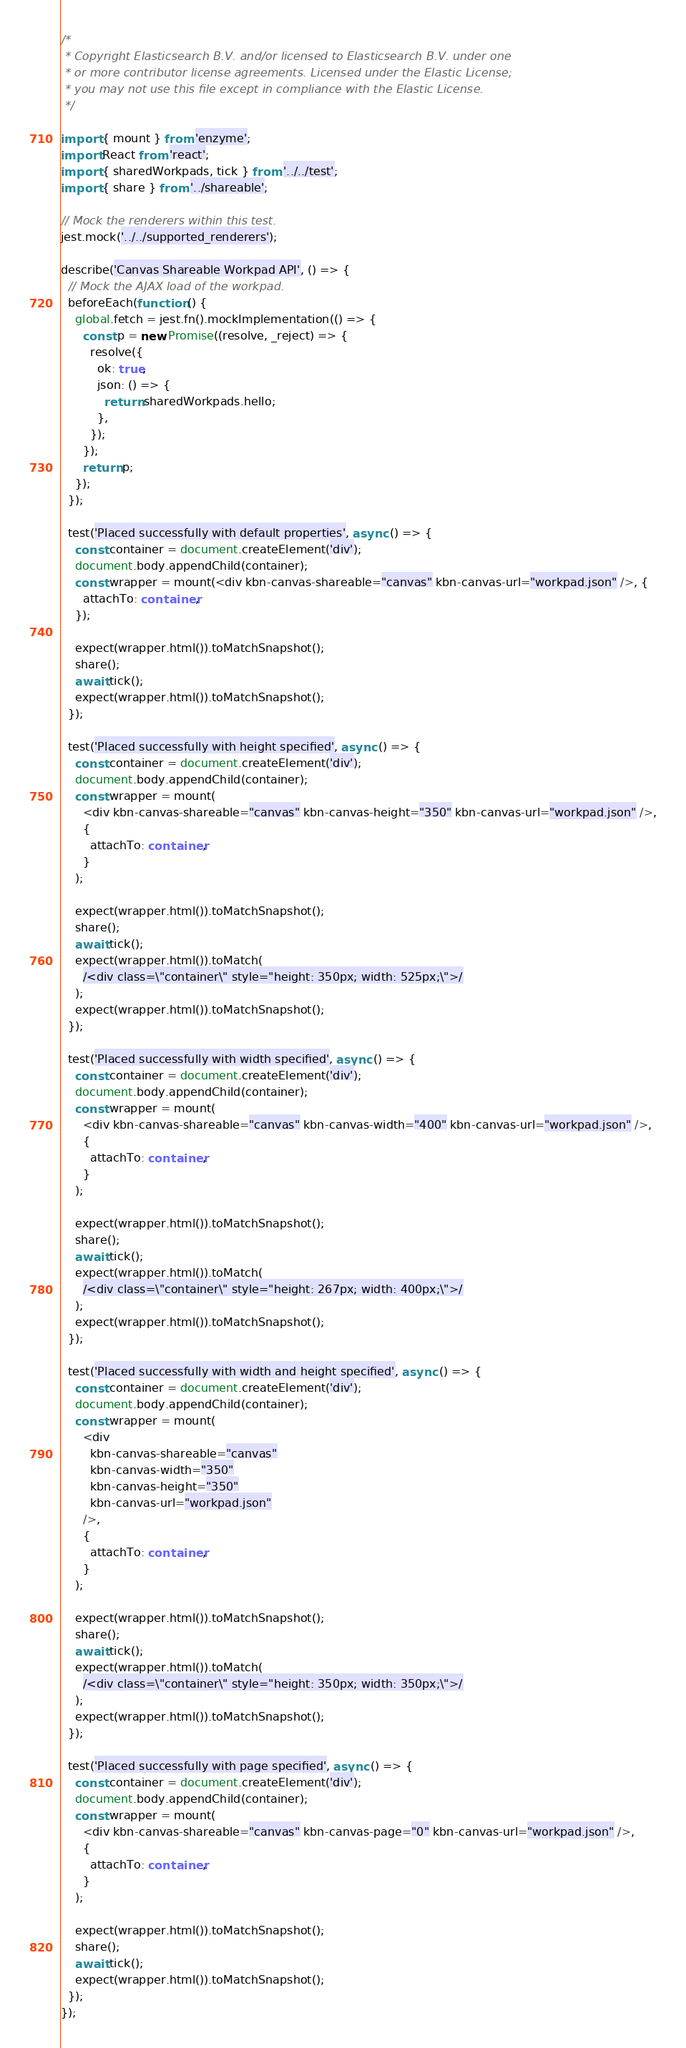Convert code to text. <code><loc_0><loc_0><loc_500><loc_500><_TypeScript_>/*
 * Copyright Elasticsearch B.V. and/or licensed to Elasticsearch B.V. under one
 * or more contributor license agreements. Licensed under the Elastic License;
 * you may not use this file except in compliance with the Elastic License.
 */

import { mount } from 'enzyme';
import React from 'react';
import { sharedWorkpads, tick } from '../../test';
import { share } from '../shareable';

// Mock the renderers within this test.
jest.mock('../../supported_renderers');

describe('Canvas Shareable Workpad API', () => {
  // Mock the AJAX load of the workpad.
  beforeEach(function () {
    global.fetch = jest.fn().mockImplementation(() => {
      const p = new Promise((resolve, _reject) => {
        resolve({
          ok: true,
          json: () => {
            return sharedWorkpads.hello;
          },
        });
      });
      return p;
    });
  });

  test('Placed successfully with default properties', async () => {
    const container = document.createElement('div');
    document.body.appendChild(container);
    const wrapper = mount(<div kbn-canvas-shareable="canvas" kbn-canvas-url="workpad.json" />, {
      attachTo: container,
    });

    expect(wrapper.html()).toMatchSnapshot();
    share();
    await tick();
    expect(wrapper.html()).toMatchSnapshot();
  });

  test('Placed successfully with height specified', async () => {
    const container = document.createElement('div');
    document.body.appendChild(container);
    const wrapper = mount(
      <div kbn-canvas-shareable="canvas" kbn-canvas-height="350" kbn-canvas-url="workpad.json" />,
      {
        attachTo: container,
      }
    );

    expect(wrapper.html()).toMatchSnapshot();
    share();
    await tick();
    expect(wrapper.html()).toMatch(
      /<div class=\"container\" style="height: 350px; width: 525px;\">/
    );
    expect(wrapper.html()).toMatchSnapshot();
  });

  test('Placed successfully with width specified', async () => {
    const container = document.createElement('div');
    document.body.appendChild(container);
    const wrapper = mount(
      <div kbn-canvas-shareable="canvas" kbn-canvas-width="400" kbn-canvas-url="workpad.json" />,
      {
        attachTo: container,
      }
    );

    expect(wrapper.html()).toMatchSnapshot();
    share();
    await tick();
    expect(wrapper.html()).toMatch(
      /<div class=\"container\" style="height: 267px; width: 400px;\">/
    );
    expect(wrapper.html()).toMatchSnapshot();
  });

  test('Placed successfully with width and height specified', async () => {
    const container = document.createElement('div');
    document.body.appendChild(container);
    const wrapper = mount(
      <div
        kbn-canvas-shareable="canvas"
        kbn-canvas-width="350"
        kbn-canvas-height="350"
        kbn-canvas-url="workpad.json"
      />,
      {
        attachTo: container,
      }
    );

    expect(wrapper.html()).toMatchSnapshot();
    share();
    await tick();
    expect(wrapper.html()).toMatch(
      /<div class=\"container\" style="height: 350px; width: 350px;\">/
    );
    expect(wrapper.html()).toMatchSnapshot();
  });

  test('Placed successfully with page specified', async () => {
    const container = document.createElement('div');
    document.body.appendChild(container);
    const wrapper = mount(
      <div kbn-canvas-shareable="canvas" kbn-canvas-page="0" kbn-canvas-url="workpad.json" />,
      {
        attachTo: container,
      }
    );

    expect(wrapper.html()).toMatchSnapshot();
    share();
    await tick();
    expect(wrapper.html()).toMatchSnapshot();
  });
});
</code> 